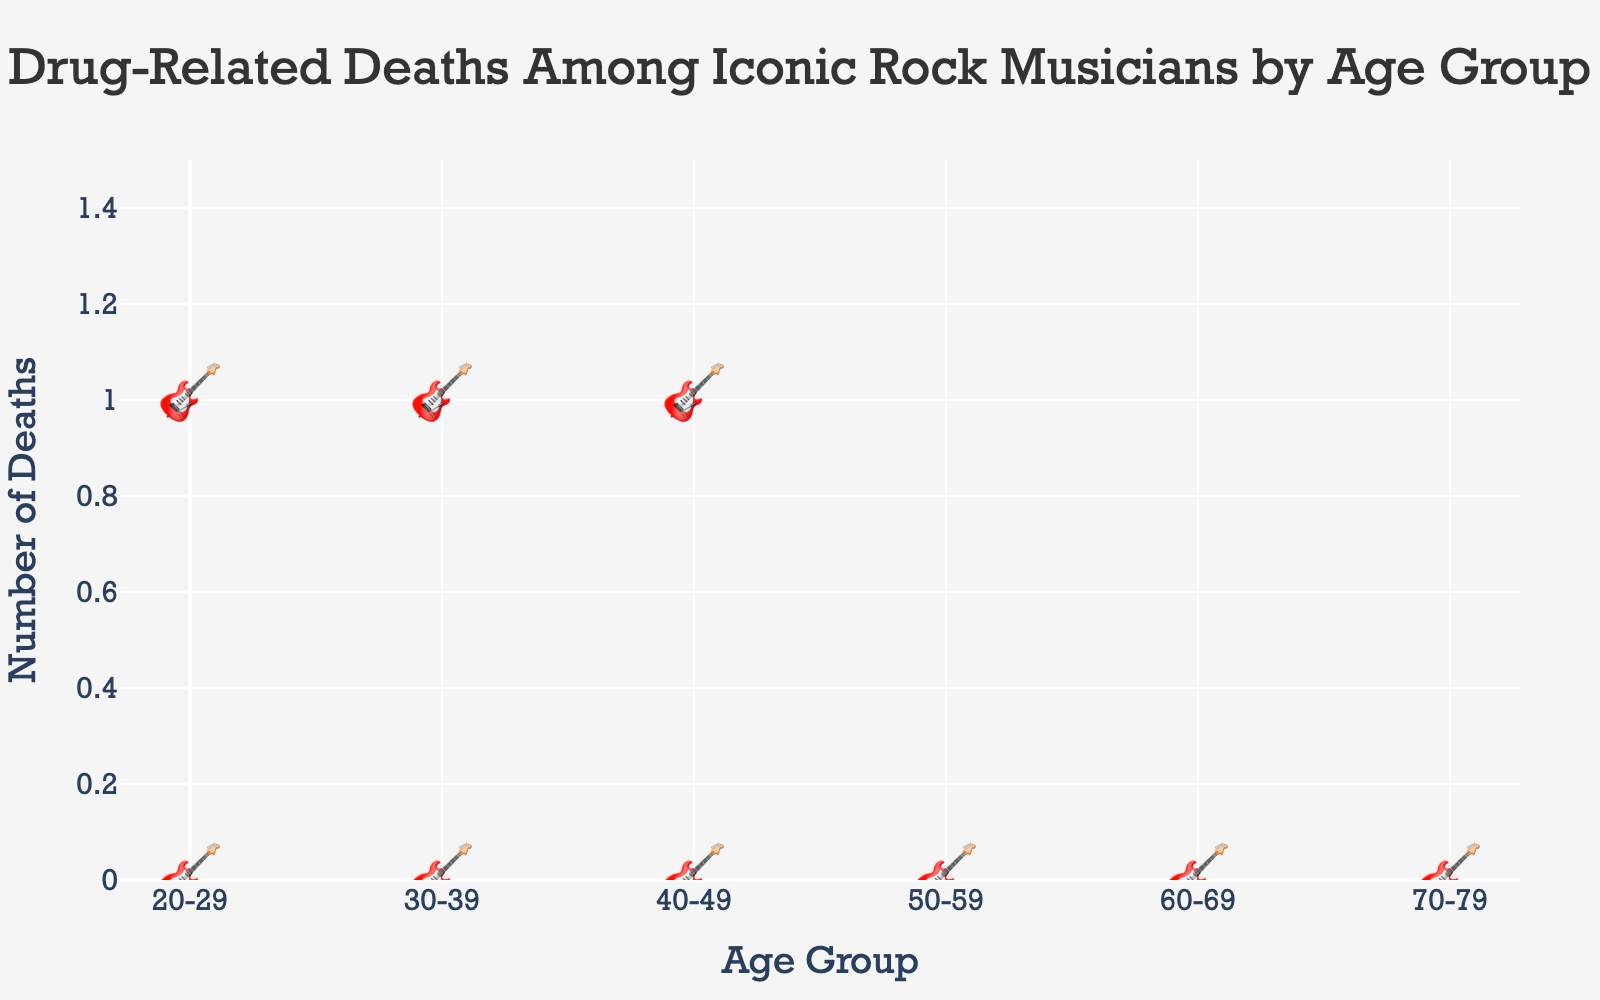What's the title of the figure? The title is typically displayed at the top of the figure. Here, it reads "Drug-Related Deaths Among Iconic Rock Musicians by Age Group".
Answer: Drug-Related Deaths Among Iconic Rock Musicians by Age Group How many age groups are represented in the figure? The age groups are shown along the x-axis and each corresponds to a specific range. By counting them, we see there are six age groups: "20-29", "30-39", "40-49", "50-59", "60-69", and "70-79".
Answer: 6 Which age group has the highest number of drug-related deaths? The figure shows guitar icons representing the number of deaths for each age group. By counting, the "20-29" age group has the highest, with 3 icons.
Answer: 20-29 What is the total number of drug-related deaths across all age groups? Adding the number of deaths represented by guitar icons across all the age groups: 3 (20-29) + 2 (30-39) + 2 (40-49) + 1 (50-59) + 1 (60-69) + 1 (70-79) = 10.
Answer: 10 How many musicians died in their 50s and 60s combined? By counting the icons, there is 1 for the "50-59" group and 1 for the "60-69" group, summing these gives 2.
Answer: 2 Which age group has more drug-related deaths, "30-39" or "50-59"? The "30-39" group has 2 icons while the "50-59" group has 1 icon.
Answer: 30-39 How many iconic rock musicians are represented by this data? Each death is depicted by a guitar icon. By summing all the icons across the age groups: 3 (20-29) + 2 (30-39) + 2 (40-49) + 1 (50-59) + 1 (60-69) + 1 (70-79) = 10.
Answer: 10 Which age group shows the lowest number of drug-related deaths, and what is the count? Age groups "50-59", "60-69", and "70-79" each have 1 guitar icon, representing the lowest number of deaths among the groups.
Answer: 50-59, 60-69, and 70-79; 1 each Are there any age groups with the same number of drug-related deaths? By observing the icons, "30-39" and "40-49" each have 2 icons, indicating that these age groups have the same number of deaths.
Answer: Yes, 30-39 and 40-49 What is the average number of drug-related deaths per age group? Total number of deaths is 10 and there are 6 age groups. The average is calculated by dividing total deaths by the number of groups: 10 / 6 ≈ 1.67.
Answer: ≈ 1.67 